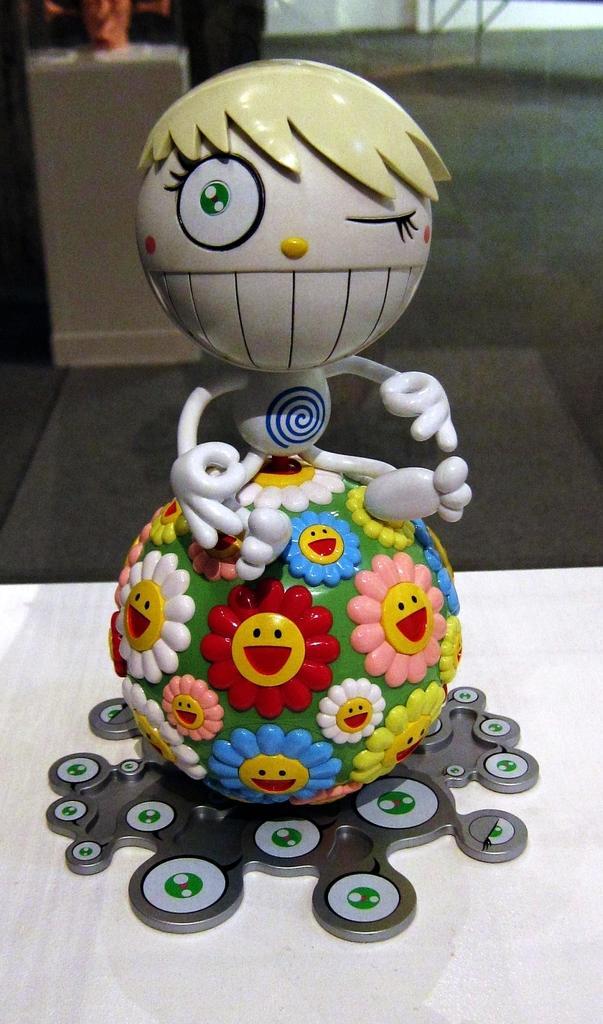How would you summarize this image in a sentence or two? In the front of the image I can see a toy on the white surface. In the background of the image it is blurry and there is an object. 